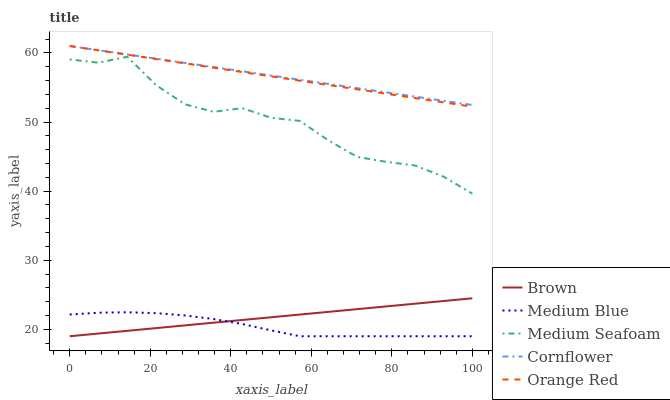Does Medium Seafoam have the minimum area under the curve?
Answer yes or no. No. Does Medium Seafoam have the maximum area under the curve?
Answer yes or no. No. Is Medium Blue the smoothest?
Answer yes or no. No. Is Medium Blue the roughest?
Answer yes or no. No. Does Medium Seafoam have the lowest value?
Answer yes or no. No. Does Medium Seafoam have the highest value?
Answer yes or no. No. Is Brown less than Cornflower?
Answer yes or no. Yes. Is Cornflower greater than Brown?
Answer yes or no. Yes. Does Brown intersect Cornflower?
Answer yes or no. No. 